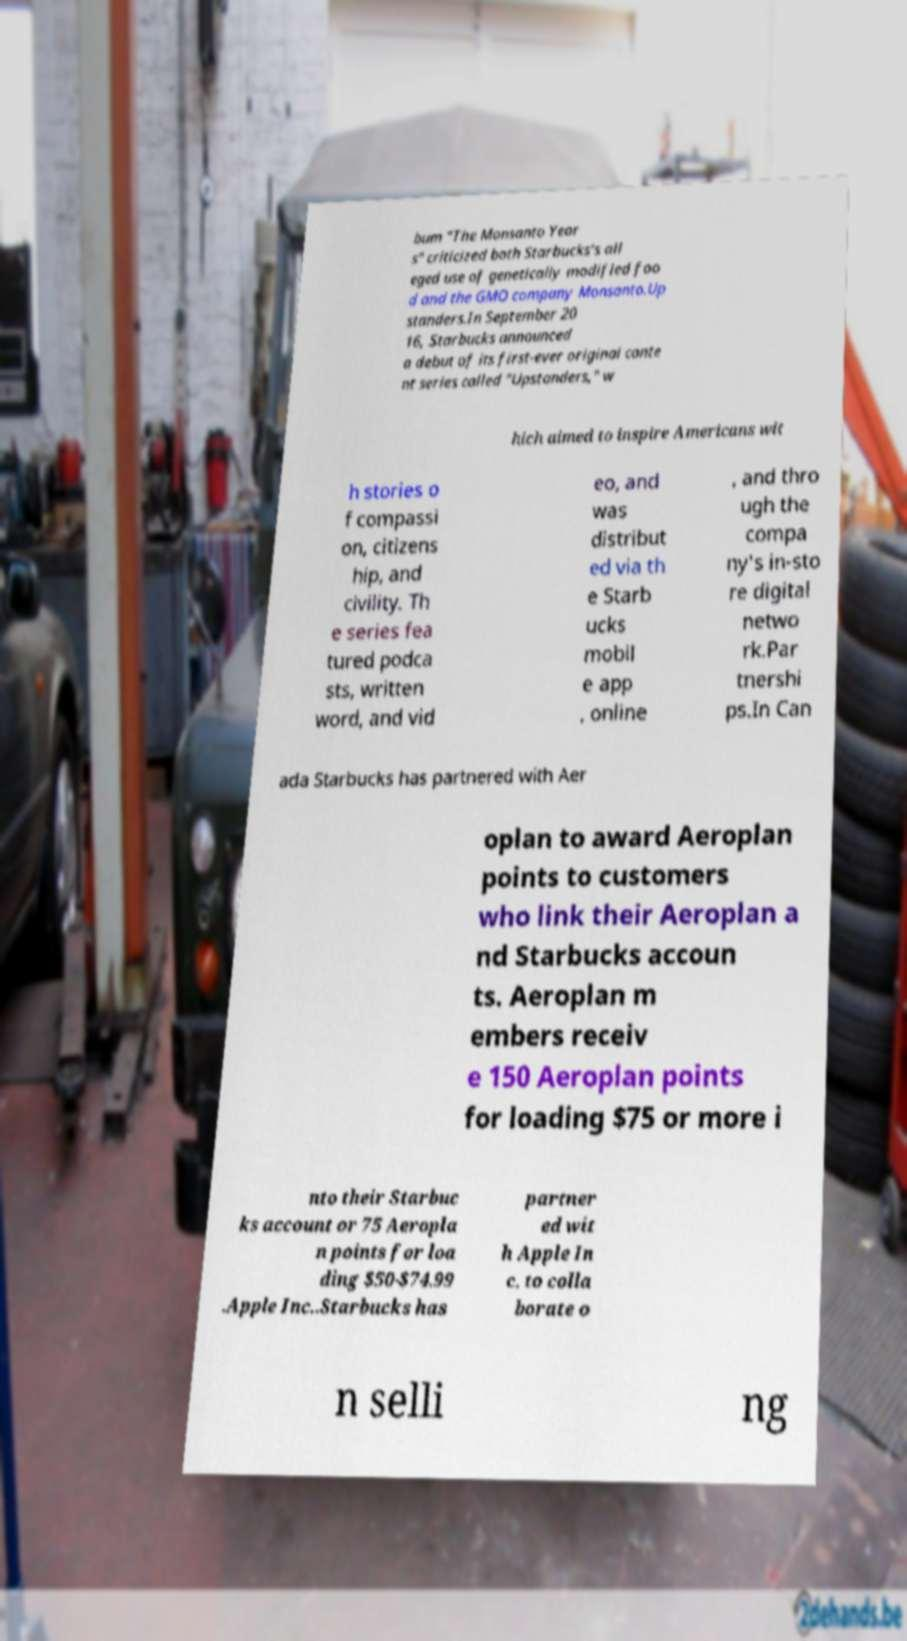Please identify and transcribe the text found in this image. bum "The Monsanto Year s" criticized both Starbucks's all eged use of genetically modified foo d and the GMO company Monsanto.Up standers.In September 20 16, Starbucks announced a debut of its first-ever original conte nt series called "Upstanders," w hich aimed to inspire Americans wit h stories o f compassi on, citizens hip, and civility. Th e series fea tured podca sts, written word, and vid eo, and was distribut ed via th e Starb ucks mobil e app , online , and thro ugh the compa ny's in-sto re digital netwo rk.Par tnershi ps.In Can ada Starbucks has partnered with Aer oplan to award Aeroplan points to customers who link their Aeroplan a nd Starbucks accoun ts. Aeroplan m embers receiv e 150 Aeroplan points for loading $75 or more i nto their Starbuc ks account or 75 Aeropla n points for loa ding $50-$74.99 .Apple Inc..Starbucks has partner ed wit h Apple In c. to colla borate o n selli ng 